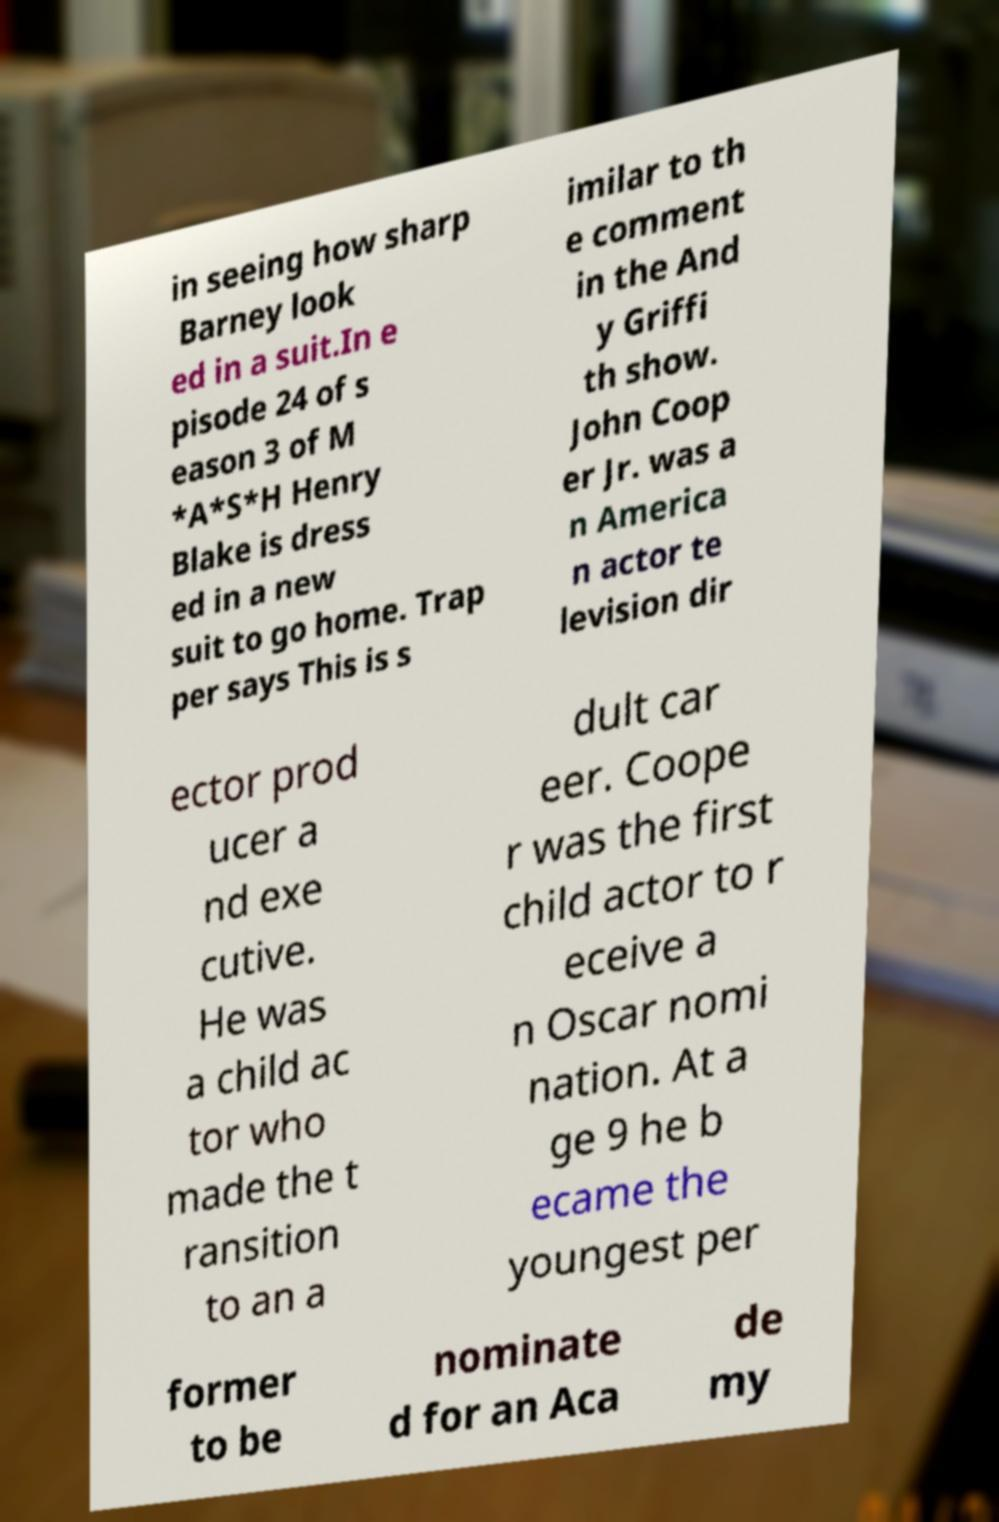Please identify and transcribe the text found in this image. in seeing how sharp Barney look ed in a suit.In e pisode 24 of s eason 3 of M *A*S*H Henry Blake is dress ed in a new suit to go home. Trap per says This is s imilar to th e comment in the And y Griffi th show. John Coop er Jr. was a n America n actor te levision dir ector prod ucer a nd exe cutive. He was a child ac tor who made the t ransition to an a dult car eer. Coope r was the first child actor to r eceive a n Oscar nomi nation. At a ge 9 he b ecame the youngest per former to be nominate d for an Aca de my 